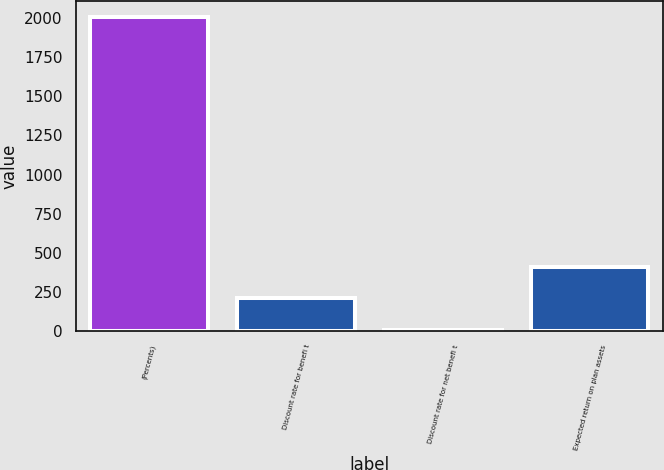Convert chart. <chart><loc_0><loc_0><loc_500><loc_500><bar_chart><fcel>(Percents)<fcel>Discount rate for benefi t<fcel>Discount rate for net benefi t<fcel>Expected return on plan assets<nl><fcel>2008<fcel>206.56<fcel>6.4<fcel>406.72<nl></chart> 